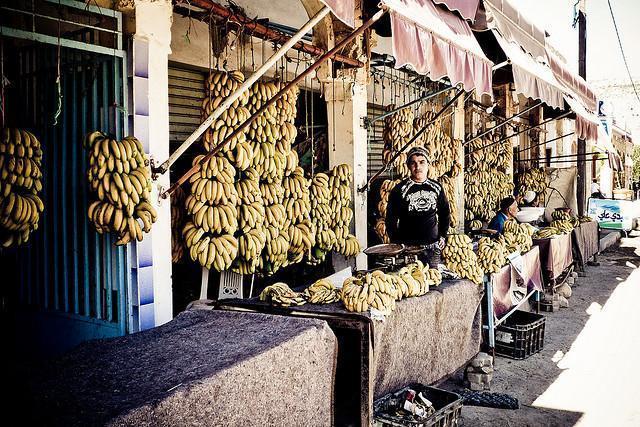How many bananas can be seen?
Give a very brief answer. 2. How many motorcycles have a helmet on the handle bars?
Give a very brief answer. 0. 